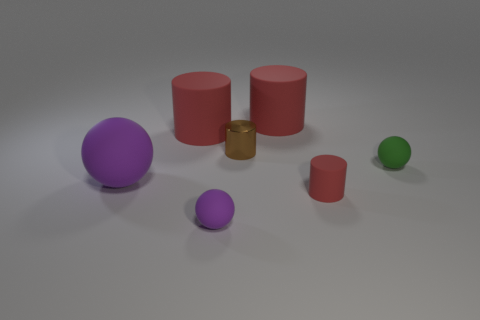How many red cylinders must be subtracted to get 1 red cylinders? 2 Subtract all red balls. How many red cylinders are left? 3 Subtract all brown cylinders. How many cylinders are left? 3 Subtract all brown cylinders. How many cylinders are left? 3 Subtract 2 cylinders. How many cylinders are left? 2 Subtract all blue cylinders. Subtract all blue spheres. How many cylinders are left? 4 Add 3 tiny purple blocks. How many objects exist? 10 Subtract all cylinders. How many objects are left? 3 Subtract all tiny green things. Subtract all large purple matte balls. How many objects are left? 5 Add 6 large red rubber things. How many large red rubber things are left? 8 